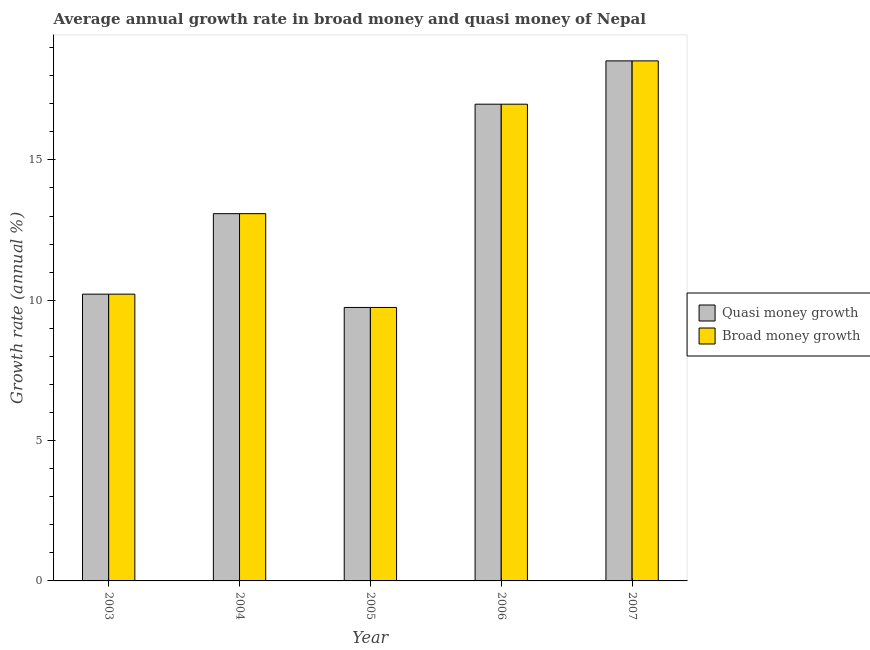How many groups of bars are there?
Make the answer very short. 5. Are the number of bars per tick equal to the number of legend labels?
Your response must be concise. Yes. How many bars are there on the 1st tick from the right?
Your answer should be compact. 2. What is the label of the 2nd group of bars from the left?
Offer a very short reply. 2004. In how many cases, is the number of bars for a given year not equal to the number of legend labels?
Offer a very short reply. 0. What is the annual growth rate in broad money in 2007?
Provide a succinct answer. 18.53. Across all years, what is the maximum annual growth rate in broad money?
Your answer should be very brief. 18.53. Across all years, what is the minimum annual growth rate in broad money?
Your answer should be very brief. 9.74. In which year was the annual growth rate in quasi money maximum?
Your answer should be very brief. 2007. What is the total annual growth rate in quasi money in the graph?
Make the answer very short. 68.56. What is the difference between the annual growth rate in quasi money in 2004 and that in 2007?
Provide a short and direct response. -5.44. What is the difference between the annual growth rate in broad money in 2006 and the annual growth rate in quasi money in 2007?
Offer a terse response. -1.54. What is the average annual growth rate in broad money per year?
Your response must be concise. 13.71. In the year 2003, what is the difference between the annual growth rate in quasi money and annual growth rate in broad money?
Your answer should be compact. 0. What is the ratio of the annual growth rate in quasi money in 2004 to that in 2006?
Offer a terse response. 0.77. Is the difference between the annual growth rate in broad money in 2004 and 2006 greater than the difference between the annual growth rate in quasi money in 2004 and 2006?
Ensure brevity in your answer.  No. What is the difference between the highest and the second highest annual growth rate in broad money?
Make the answer very short. 1.54. What is the difference between the highest and the lowest annual growth rate in quasi money?
Ensure brevity in your answer.  8.79. In how many years, is the annual growth rate in quasi money greater than the average annual growth rate in quasi money taken over all years?
Your answer should be compact. 2. Is the sum of the annual growth rate in broad money in 2004 and 2005 greater than the maximum annual growth rate in quasi money across all years?
Your answer should be very brief. Yes. What does the 2nd bar from the left in 2005 represents?
Your answer should be very brief. Broad money growth. What does the 1st bar from the right in 2005 represents?
Your answer should be very brief. Broad money growth. How many years are there in the graph?
Your answer should be compact. 5. What is the difference between two consecutive major ticks on the Y-axis?
Your answer should be very brief. 5. Does the graph contain any zero values?
Your answer should be very brief. No. How are the legend labels stacked?
Your answer should be very brief. Vertical. What is the title of the graph?
Provide a succinct answer. Average annual growth rate in broad money and quasi money of Nepal. Does "From World Bank" appear as one of the legend labels in the graph?
Provide a succinct answer. No. What is the label or title of the Y-axis?
Offer a very short reply. Growth rate (annual %). What is the Growth rate (annual %) of Quasi money growth in 2003?
Offer a very short reply. 10.22. What is the Growth rate (annual %) of Broad money growth in 2003?
Ensure brevity in your answer.  10.22. What is the Growth rate (annual %) in Quasi money growth in 2004?
Your response must be concise. 13.09. What is the Growth rate (annual %) of Broad money growth in 2004?
Offer a very short reply. 13.09. What is the Growth rate (annual %) in Quasi money growth in 2005?
Offer a very short reply. 9.74. What is the Growth rate (annual %) of Broad money growth in 2005?
Make the answer very short. 9.74. What is the Growth rate (annual %) in Quasi money growth in 2006?
Give a very brief answer. 16.99. What is the Growth rate (annual %) of Broad money growth in 2006?
Your response must be concise. 16.99. What is the Growth rate (annual %) in Quasi money growth in 2007?
Your answer should be compact. 18.53. What is the Growth rate (annual %) in Broad money growth in 2007?
Your response must be concise. 18.53. Across all years, what is the maximum Growth rate (annual %) in Quasi money growth?
Provide a short and direct response. 18.53. Across all years, what is the maximum Growth rate (annual %) in Broad money growth?
Give a very brief answer. 18.53. Across all years, what is the minimum Growth rate (annual %) of Quasi money growth?
Give a very brief answer. 9.74. Across all years, what is the minimum Growth rate (annual %) in Broad money growth?
Provide a succinct answer. 9.74. What is the total Growth rate (annual %) in Quasi money growth in the graph?
Make the answer very short. 68.56. What is the total Growth rate (annual %) of Broad money growth in the graph?
Ensure brevity in your answer.  68.56. What is the difference between the Growth rate (annual %) in Quasi money growth in 2003 and that in 2004?
Make the answer very short. -2.87. What is the difference between the Growth rate (annual %) of Broad money growth in 2003 and that in 2004?
Ensure brevity in your answer.  -2.87. What is the difference between the Growth rate (annual %) in Quasi money growth in 2003 and that in 2005?
Your answer should be very brief. 0.47. What is the difference between the Growth rate (annual %) in Broad money growth in 2003 and that in 2005?
Offer a terse response. 0.47. What is the difference between the Growth rate (annual %) in Quasi money growth in 2003 and that in 2006?
Provide a succinct answer. -6.77. What is the difference between the Growth rate (annual %) of Broad money growth in 2003 and that in 2006?
Your answer should be very brief. -6.77. What is the difference between the Growth rate (annual %) in Quasi money growth in 2003 and that in 2007?
Your response must be concise. -8.31. What is the difference between the Growth rate (annual %) in Broad money growth in 2003 and that in 2007?
Give a very brief answer. -8.31. What is the difference between the Growth rate (annual %) in Quasi money growth in 2004 and that in 2005?
Provide a short and direct response. 3.34. What is the difference between the Growth rate (annual %) of Broad money growth in 2004 and that in 2005?
Ensure brevity in your answer.  3.34. What is the difference between the Growth rate (annual %) in Quasi money growth in 2004 and that in 2006?
Your response must be concise. -3.9. What is the difference between the Growth rate (annual %) in Broad money growth in 2004 and that in 2006?
Your response must be concise. -3.9. What is the difference between the Growth rate (annual %) of Quasi money growth in 2004 and that in 2007?
Make the answer very short. -5.44. What is the difference between the Growth rate (annual %) in Broad money growth in 2004 and that in 2007?
Provide a short and direct response. -5.44. What is the difference between the Growth rate (annual %) in Quasi money growth in 2005 and that in 2006?
Keep it short and to the point. -7.24. What is the difference between the Growth rate (annual %) of Broad money growth in 2005 and that in 2006?
Ensure brevity in your answer.  -7.24. What is the difference between the Growth rate (annual %) in Quasi money growth in 2005 and that in 2007?
Provide a succinct answer. -8.79. What is the difference between the Growth rate (annual %) of Broad money growth in 2005 and that in 2007?
Your answer should be very brief. -8.79. What is the difference between the Growth rate (annual %) of Quasi money growth in 2006 and that in 2007?
Keep it short and to the point. -1.54. What is the difference between the Growth rate (annual %) of Broad money growth in 2006 and that in 2007?
Provide a succinct answer. -1.54. What is the difference between the Growth rate (annual %) in Quasi money growth in 2003 and the Growth rate (annual %) in Broad money growth in 2004?
Offer a terse response. -2.87. What is the difference between the Growth rate (annual %) of Quasi money growth in 2003 and the Growth rate (annual %) of Broad money growth in 2005?
Offer a very short reply. 0.47. What is the difference between the Growth rate (annual %) in Quasi money growth in 2003 and the Growth rate (annual %) in Broad money growth in 2006?
Keep it short and to the point. -6.77. What is the difference between the Growth rate (annual %) in Quasi money growth in 2003 and the Growth rate (annual %) in Broad money growth in 2007?
Ensure brevity in your answer.  -8.31. What is the difference between the Growth rate (annual %) of Quasi money growth in 2004 and the Growth rate (annual %) of Broad money growth in 2005?
Provide a short and direct response. 3.34. What is the difference between the Growth rate (annual %) in Quasi money growth in 2004 and the Growth rate (annual %) in Broad money growth in 2006?
Make the answer very short. -3.9. What is the difference between the Growth rate (annual %) in Quasi money growth in 2004 and the Growth rate (annual %) in Broad money growth in 2007?
Your answer should be very brief. -5.44. What is the difference between the Growth rate (annual %) of Quasi money growth in 2005 and the Growth rate (annual %) of Broad money growth in 2006?
Make the answer very short. -7.24. What is the difference between the Growth rate (annual %) of Quasi money growth in 2005 and the Growth rate (annual %) of Broad money growth in 2007?
Offer a terse response. -8.79. What is the difference between the Growth rate (annual %) of Quasi money growth in 2006 and the Growth rate (annual %) of Broad money growth in 2007?
Offer a terse response. -1.54. What is the average Growth rate (annual %) in Quasi money growth per year?
Ensure brevity in your answer.  13.71. What is the average Growth rate (annual %) of Broad money growth per year?
Offer a terse response. 13.71. In the year 2004, what is the difference between the Growth rate (annual %) of Quasi money growth and Growth rate (annual %) of Broad money growth?
Make the answer very short. 0. In the year 2006, what is the difference between the Growth rate (annual %) in Quasi money growth and Growth rate (annual %) in Broad money growth?
Your response must be concise. 0. In the year 2007, what is the difference between the Growth rate (annual %) of Quasi money growth and Growth rate (annual %) of Broad money growth?
Make the answer very short. 0. What is the ratio of the Growth rate (annual %) in Quasi money growth in 2003 to that in 2004?
Keep it short and to the point. 0.78. What is the ratio of the Growth rate (annual %) in Broad money growth in 2003 to that in 2004?
Provide a succinct answer. 0.78. What is the ratio of the Growth rate (annual %) in Quasi money growth in 2003 to that in 2005?
Offer a terse response. 1.05. What is the ratio of the Growth rate (annual %) of Broad money growth in 2003 to that in 2005?
Make the answer very short. 1.05. What is the ratio of the Growth rate (annual %) of Quasi money growth in 2003 to that in 2006?
Keep it short and to the point. 0.6. What is the ratio of the Growth rate (annual %) in Broad money growth in 2003 to that in 2006?
Offer a very short reply. 0.6. What is the ratio of the Growth rate (annual %) in Quasi money growth in 2003 to that in 2007?
Your answer should be very brief. 0.55. What is the ratio of the Growth rate (annual %) in Broad money growth in 2003 to that in 2007?
Keep it short and to the point. 0.55. What is the ratio of the Growth rate (annual %) in Quasi money growth in 2004 to that in 2005?
Provide a short and direct response. 1.34. What is the ratio of the Growth rate (annual %) of Broad money growth in 2004 to that in 2005?
Provide a succinct answer. 1.34. What is the ratio of the Growth rate (annual %) in Quasi money growth in 2004 to that in 2006?
Your response must be concise. 0.77. What is the ratio of the Growth rate (annual %) of Broad money growth in 2004 to that in 2006?
Keep it short and to the point. 0.77. What is the ratio of the Growth rate (annual %) in Quasi money growth in 2004 to that in 2007?
Offer a very short reply. 0.71. What is the ratio of the Growth rate (annual %) of Broad money growth in 2004 to that in 2007?
Provide a short and direct response. 0.71. What is the ratio of the Growth rate (annual %) of Quasi money growth in 2005 to that in 2006?
Provide a succinct answer. 0.57. What is the ratio of the Growth rate (annual %) in Broad money growth in 2005 to that in 2006?
Ensure brevity in your answer.  0.57. What is the ratio of the Growth rate (annual %) in Quasi money growth in 2005 to that in 2007?
Your answer should be very brief. 0.53. What is the ratio of the Growth rate (annual %) in Broad money growth in 2005 to that in 2007?
Ensure brevity in your answer.  0.53. What is the ratio of the Growth rate (annual %) in Quasi money growth in 2006 to that in 2007?
Offer a terse response. 0.92. What is the ratio of the Growth rate (annual %) in Broad money growth in 2006 to that in 2007?
Your answer should be very brief. 0.92. What is the difference between the highest and the second highest Growth rate (annual %) of Quasi money growth?
Keep it short and to the point. 1.54. What is the difference between the highest and the second highest Growth rate (annual %) in Broad money growth?
Keep it short and to the point. 1.54. What is the difference between the highest and the lowest Growth rate (annual %) of Quasi money growth?
Your answer should be very brief. 8.79. What is the difference between the highest and the lowest Growth rate (annual %) of Broad money growth?
Make the answer very short. 8.79. 